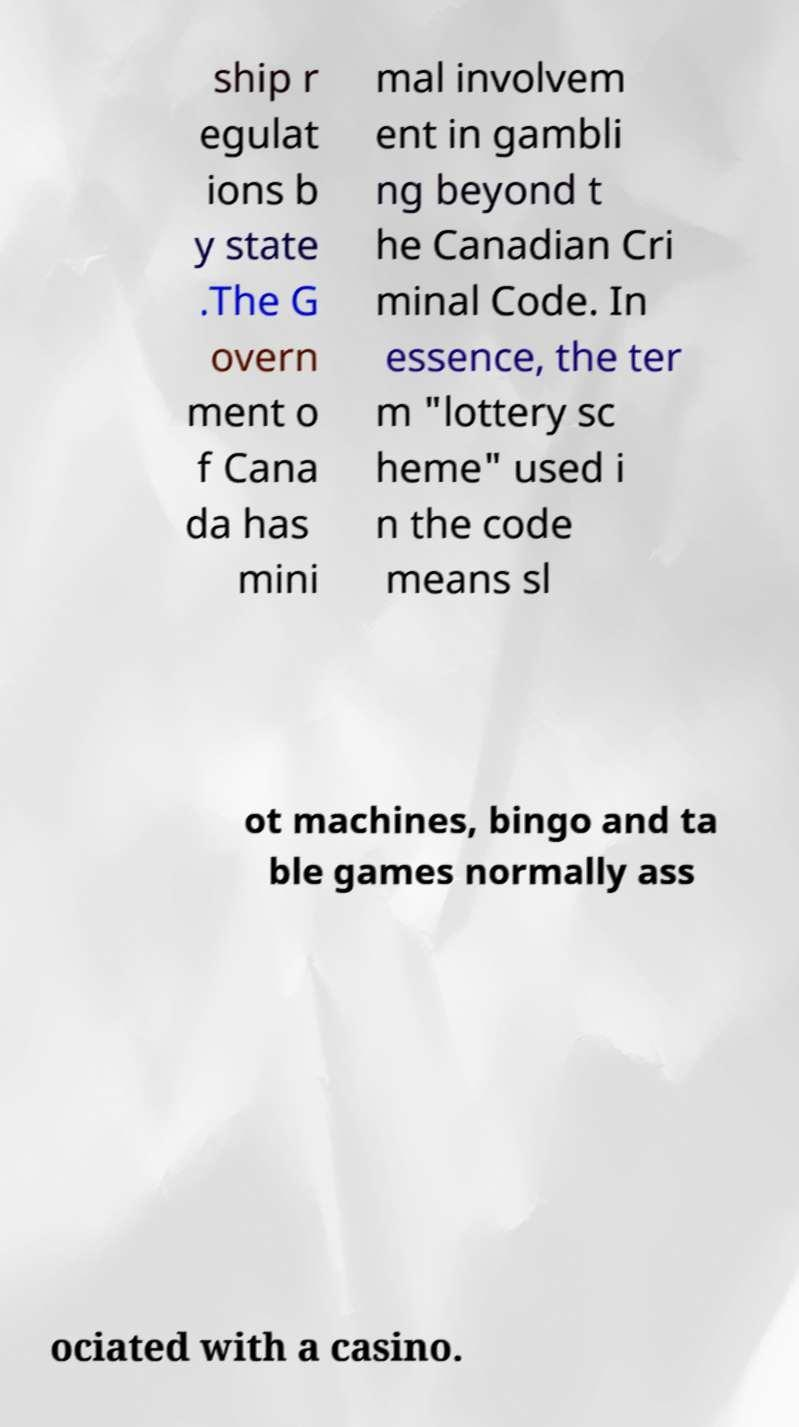Please identify and transcribe the text found in this image. ship r egulat ions b y state .The G overn ment o f Cana da has mini mal involvem ent in gambli ng beyond t he Canadian Cri minal Code. In essence, the ter m "lottery sc heme" used i n the code means sl ot machines, bingo and ta ble games normally ass ociated with a casino. 